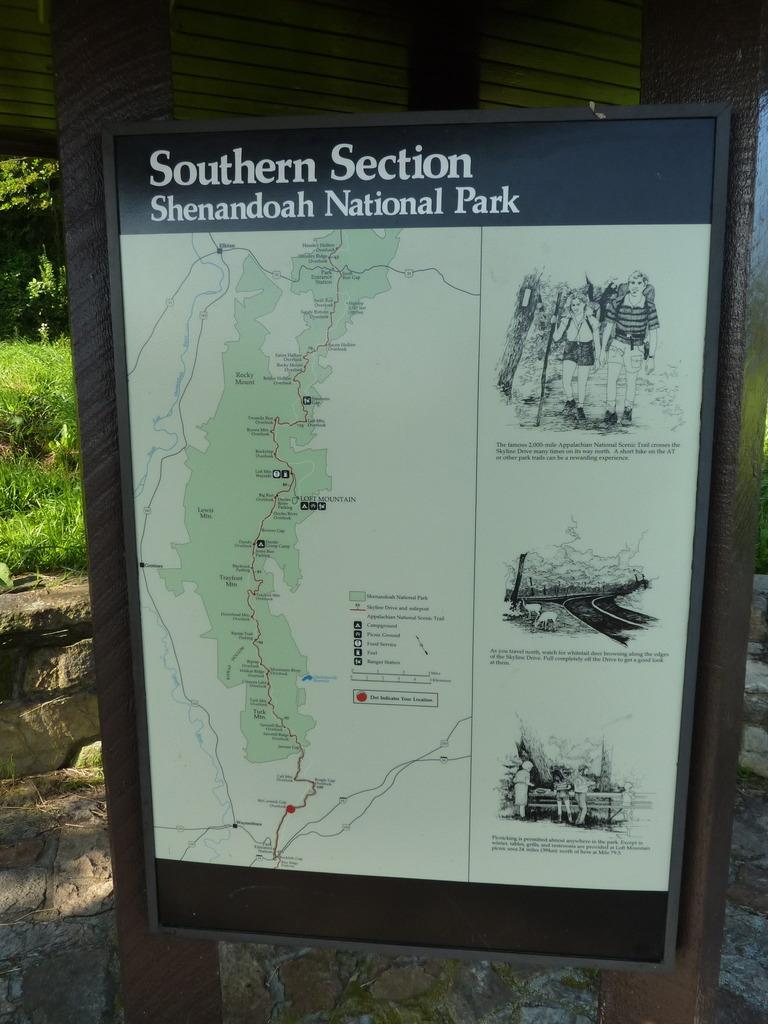What is the main object in the center of the image? There is a banner in the center of the image. What can be found on the banner? The banner has text and images on it. What type of vegetation is visible in the background of the image? There are trees in the background of the image. What is the ground made of in the image? There is grass on the ground in the image. How many mittens can be seen hanging from the trees in the image? There are no mittens present in the image; it features a banner with text and images, trees in the background, and grass on the ground. What type of pin is holding the banner in place in the image? There is no pin visible in the image; the banner is not shown to be held in place by any specific object. 